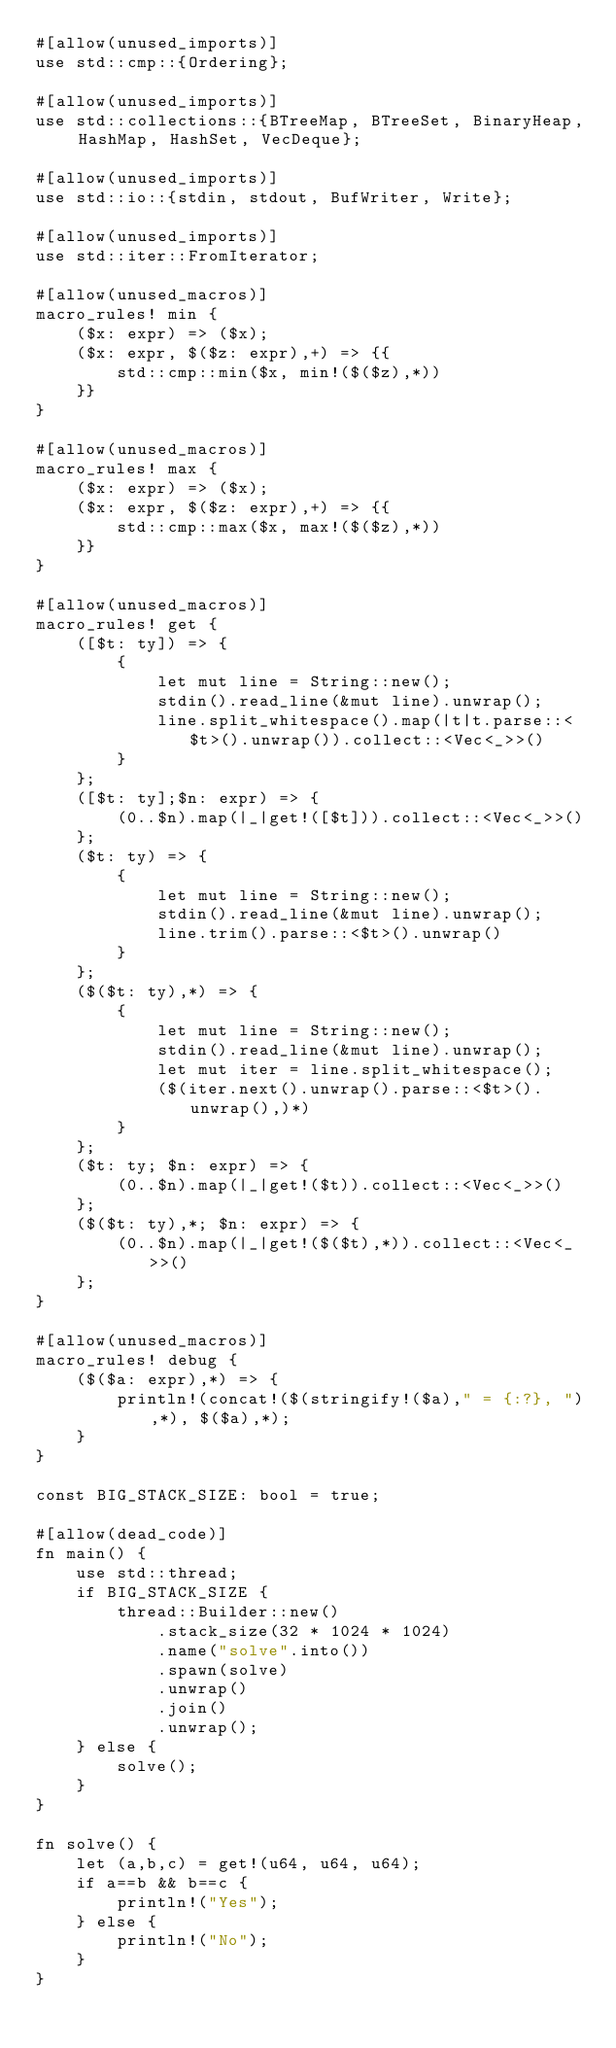<code> <loc_0><loc_0><loc_500><loc_500><_Rust_>#[allow(unused_imports)]
use std::cmp::{Ordering};

#[allow(unused_imports)]
use std::collections::{BTreeMap, BTreeSet, BinaryHeap, HashMap, HashSet, VecDeque};

#[allow(unused_imports)]
use std::io::{stdin, stdout, BufWriter, Write};

#[allow(unused_imports)]
use std::iter::FromIterator;

#[allow(unused_macros)]
macro_rules! min {
    ($x: expr) => ($x);
    ($x: expr, $($z: expr),+) => {{
        std::cmp::min($x, min!($($z),*))
    }}
}

#[allow(unused_macros)]
macro_rules! max {
    ($x: expr) => ($x);
    ($x: expr, $($z: expr),+) => {{
        std::cmp::max($x, max!($($z),*))
    }}
}

#[allow(unused_macros)]
macro_rules! get { 
    ([$t: ty]) => { 
        { 
            let mut line = String::new(); 
            stdin().read_line(&mut line).unwrap(); 
            line.split_whitespace().map(|t|t.parse::<$t>().unwrap()).collect::<Vec<_>>()
        }
    };
    ([$t: ty];$n: expr) => {
        (0..$n).map(|_|get!([$t])).collect::<Vec<_>>()
    };
    ($t: ty) => {
        {
            let mut line = String::new();
            stdin().read_line(&mut line).unwrap();
            line.trim().parse::<$t>().unwrap()
        }
    };
    ($($t: ty),*) => {
        { 
            let mut line = String::new();
            stdin().read_line(&mut line).unwrap();
            let mut iter = line.split_whitespace();
            ($(iter.next().unwrap().parse::<$t>().unwrap(),)*)
        }
    };
    ($t: ty; $n: expr) => {
        (0..$n).map(|_|get!($t)).collect::<Vec<_>>()
    };
    ($($t: ty),*; $n: expr) => {
        (0..$n).map(|_|get!($($t),*)).collect::<Vec<_>>()
    };
}

#[allow(unused_macros)]
macro_rules! debug { 
    ($($a: expr),*) => { 
        println!(concat!($(stringify!($a)," = {:?}, "),*), $($a),*);
    } 
}

const BIG_STACK_SIZE: bool = true;

#[allow(dead_code)]
fn main() {
    use std::thread;
    if BIG_STACK_SIZE {
        thread::Builder::new()
            .stack_size(32 * 1024 * 1024)
            .name("solve".into())
            .spawn(solve)
            .unwrap()
            .join()
            .unwrap();
    } else {
        solve();
    }
}

fn solve() {
    let (a,b,c) = get!(u64, u64, u64);
    if a==b && b==c {
        println!("Yes");
    } else {
        println!("No");
    }
}
</code> 